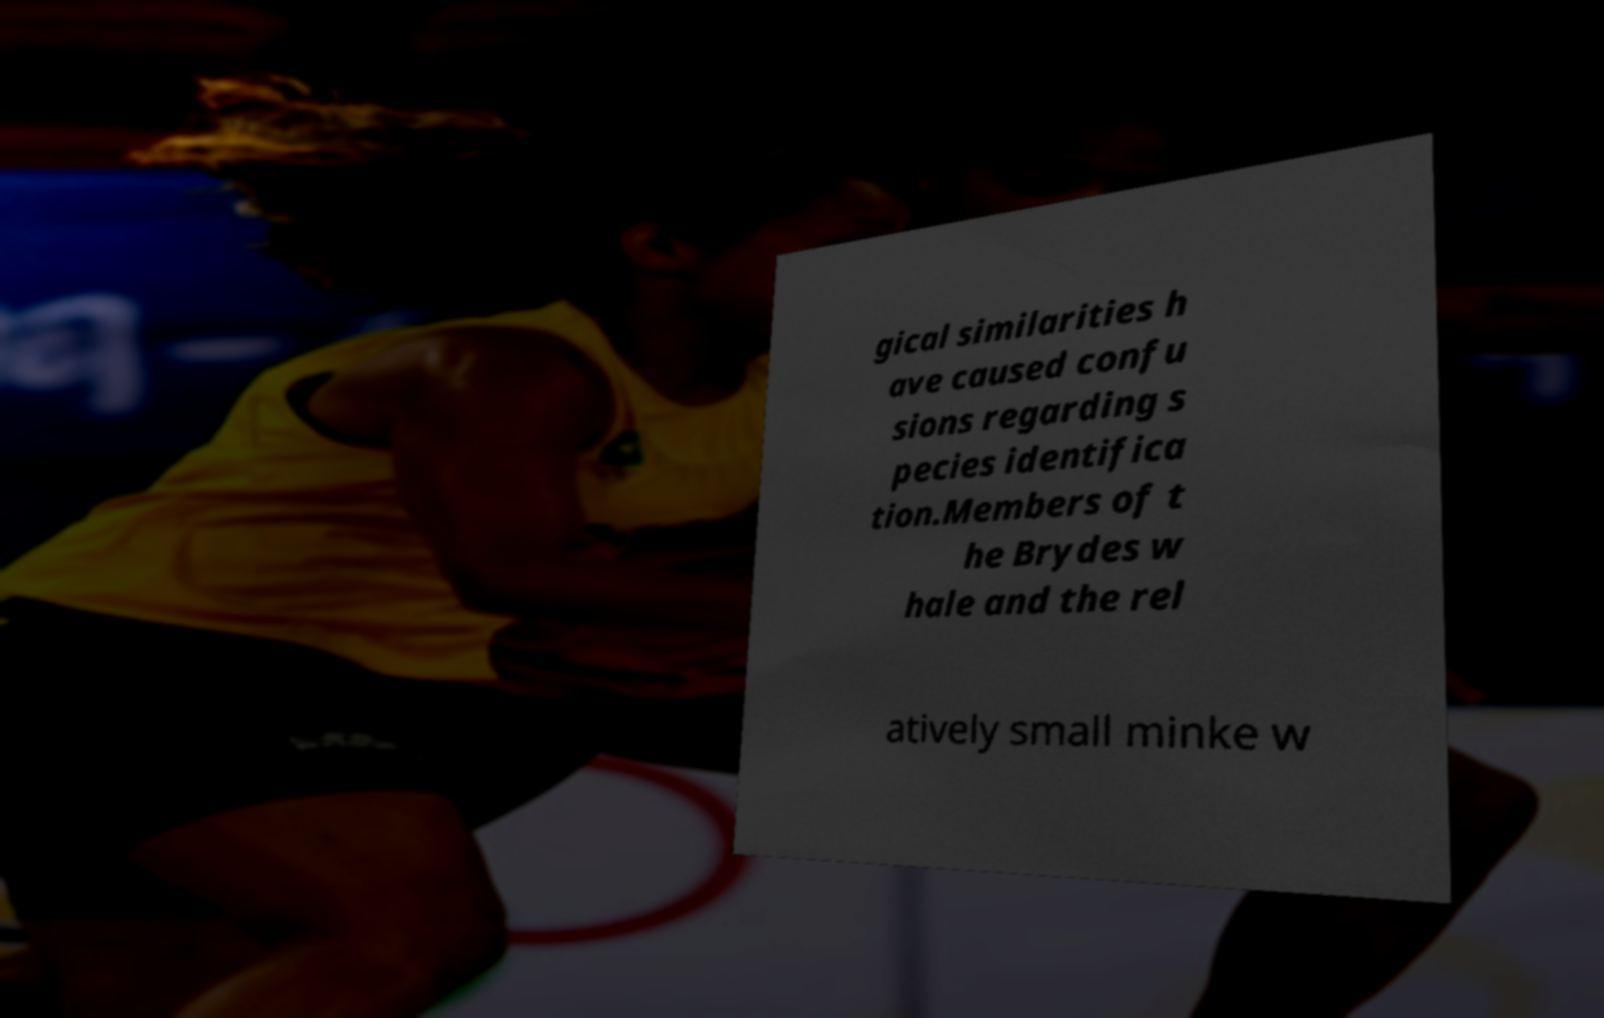Please read and relay the text visible in this image. What does it say? gical similarities h ave caused confu sions regarding s pecies identifica tion.Members of t he Brydes w hale and the rel atively small minke w 